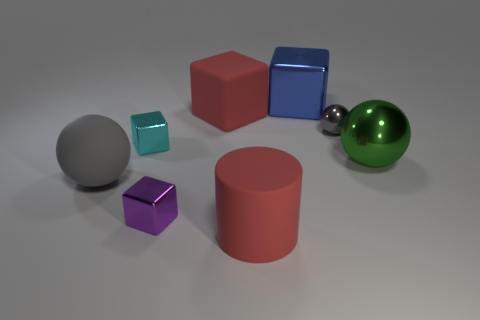Which object in this scene do you think weighs the most, and why? Assuming the objects are made from materials with density corresponding to their appearance, the big blue cube likely weighs the most due to its size and the fact that it looks to be made of a metallic or dense material, which is commonly heavier than plastics or other less dense materials. 